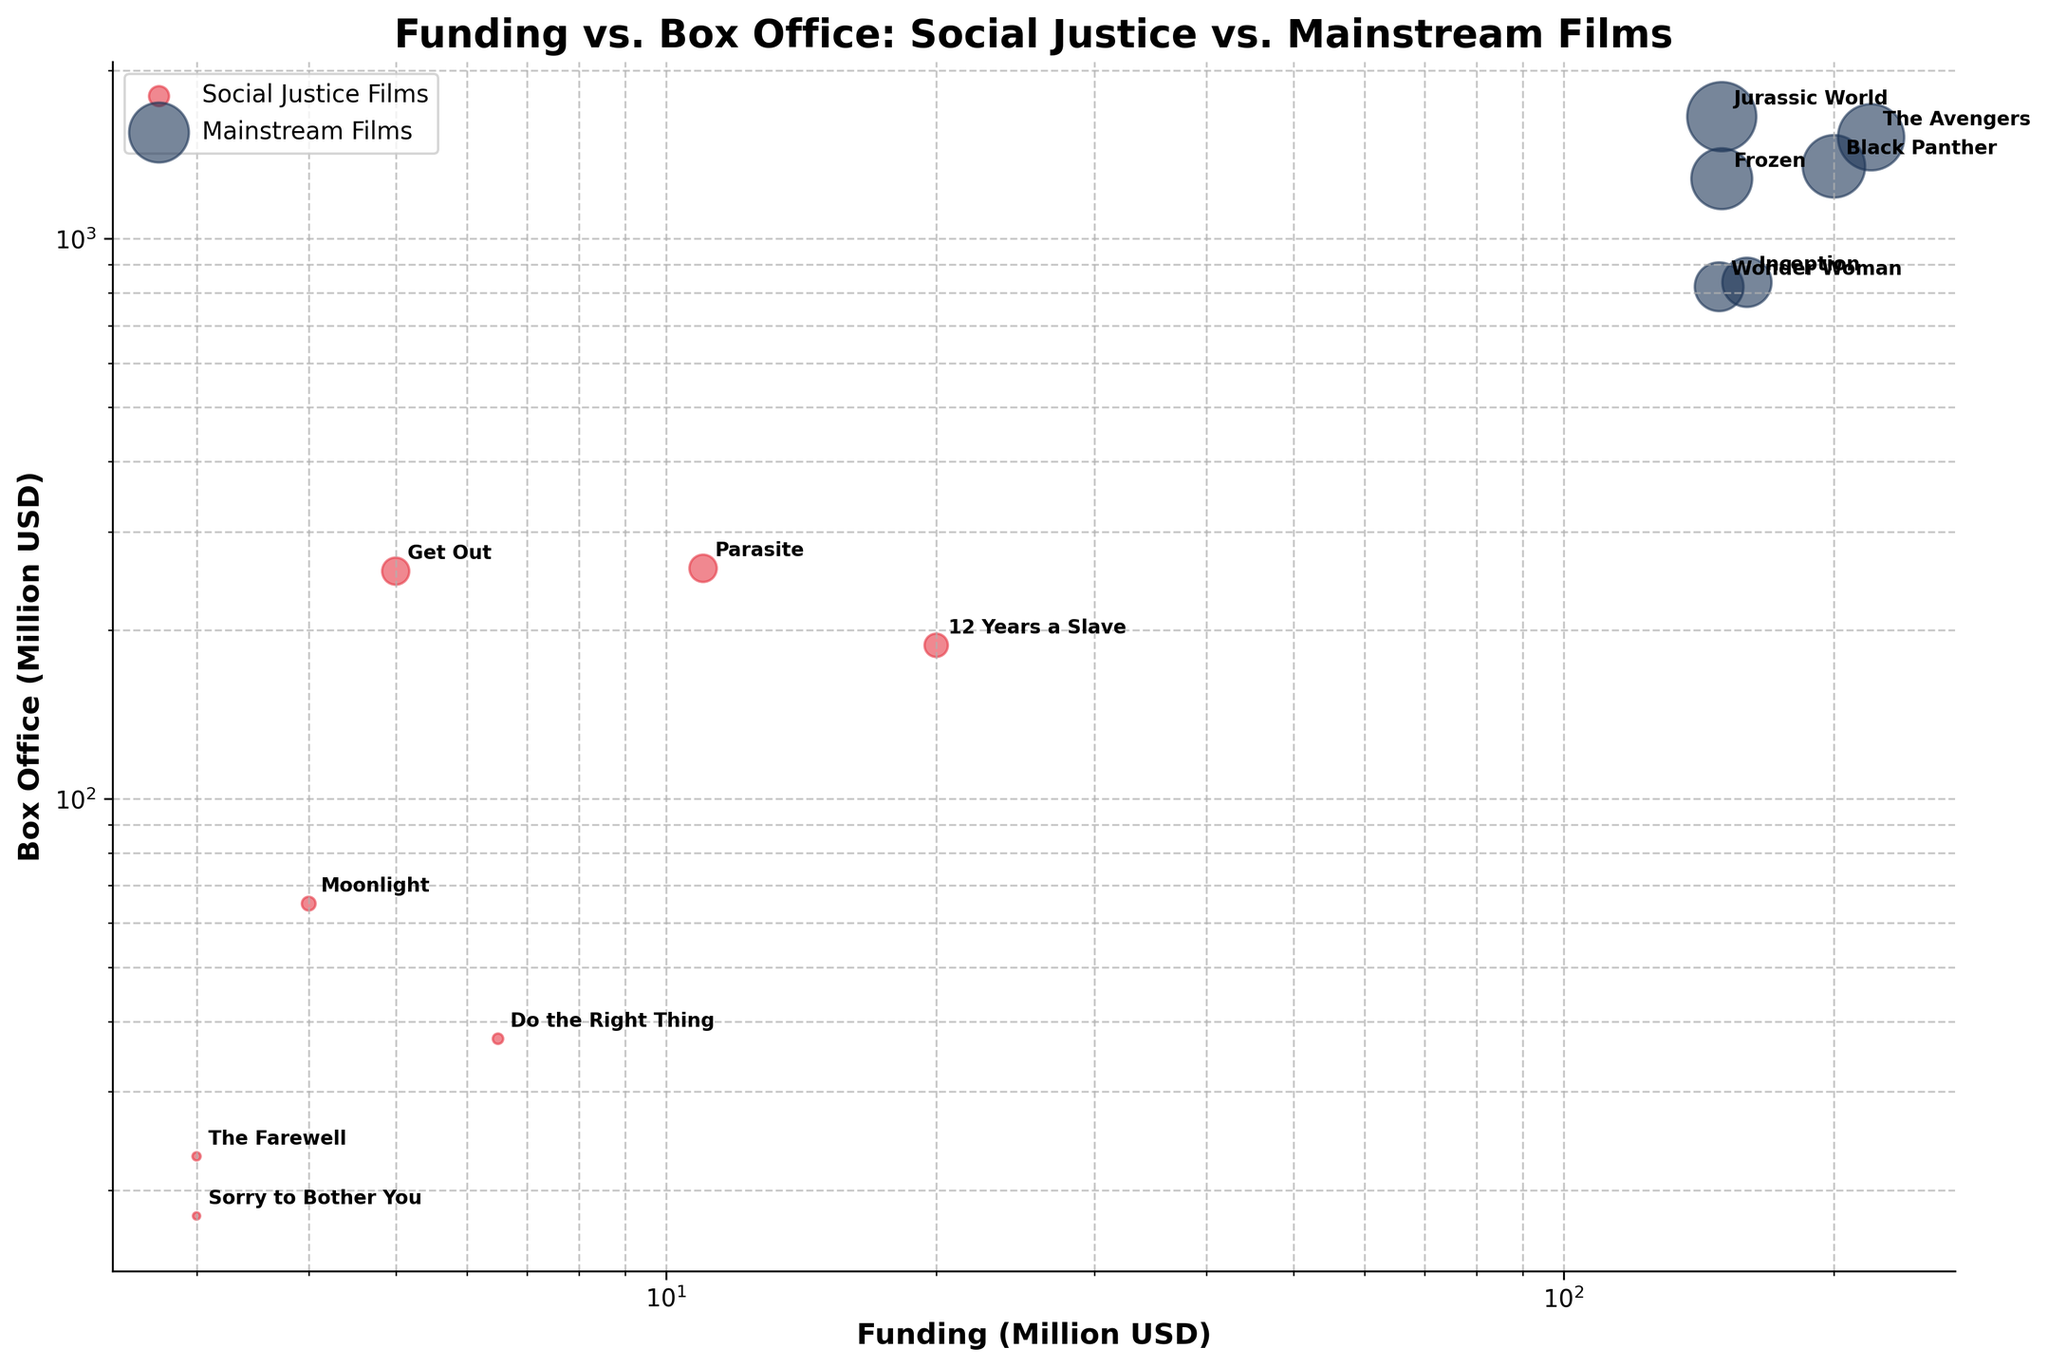How many films in total are represented in the figure? The figure represents a bubble chart with data points for each film. We count the total unique films presented in the scatter plot by identifying their titles.
Answer: 12 Which film received the highest funding among social justice films? By looking at the social justice films marked in red, we can see that "12 Years a Slave" has the highest funding value at 20 million USD.
Answer: 12 Years a Slave Which film has the highest box office revenue among mainstream films? By inspecting the blue bubbles representing mainstream films, "Jurassic World" has the highest box office revenue at 1652 million USD.
Answer: Jurassic World How does the funding of "Get Out" compare to "Do the Right Thing"? "Get Out" has a funding of 5 million USD, while "Do the Right Thing" has a funding of 6.5 million USD. Therefore, "Do the Right Thing" received more funding.
Answer: Do the Right Thing has more funding What is the ratio of funding to box office revenue for "Parasite"? "Parasite" has a funding of 11 million USD and box office revenue of 258 million USD. The ratio is calculated as 11/258.
Answer: 0.0426 Compare the funding versus box office revenue between social justice and mainstream films. Which category seems to achieve higher box office revenue relative to funding on average? By observing the scatter plot, we see that while mainstream films generally have higher funding, social justice films tend to have a higher box office return relative to their funding. Examples are "Get Out" and "Moonlight", both showing high revenue with low funding. Mainstream films like "The Avengers" also perform well, but considering the funding ratio, social justice films appear to have more box office success relative to their lower budgets.
Answer: Social Justice Films What's the number of bubbles representing social justice films? By counting the number of red bubbles representing social justice films in the scatter plot, we find there are 7 bubbles.
Answer: 7 Which film has the lowest box office revenue among social justice films? The social justice film with the lowest box office revenue is identified by the smallest red bubble along the Y-axis, which is "Sorry to Bother You" with 18 million USD.
Answer: Sorry to Bother You Which social justice film has a box office revenue closest to 50 million USD? By inspecting the Y-axis for social justice films around 50 million USD, "Moonlight" has a box office revenue of 65 million USD, which is the closest among the given films.
Answer: Moonlight 